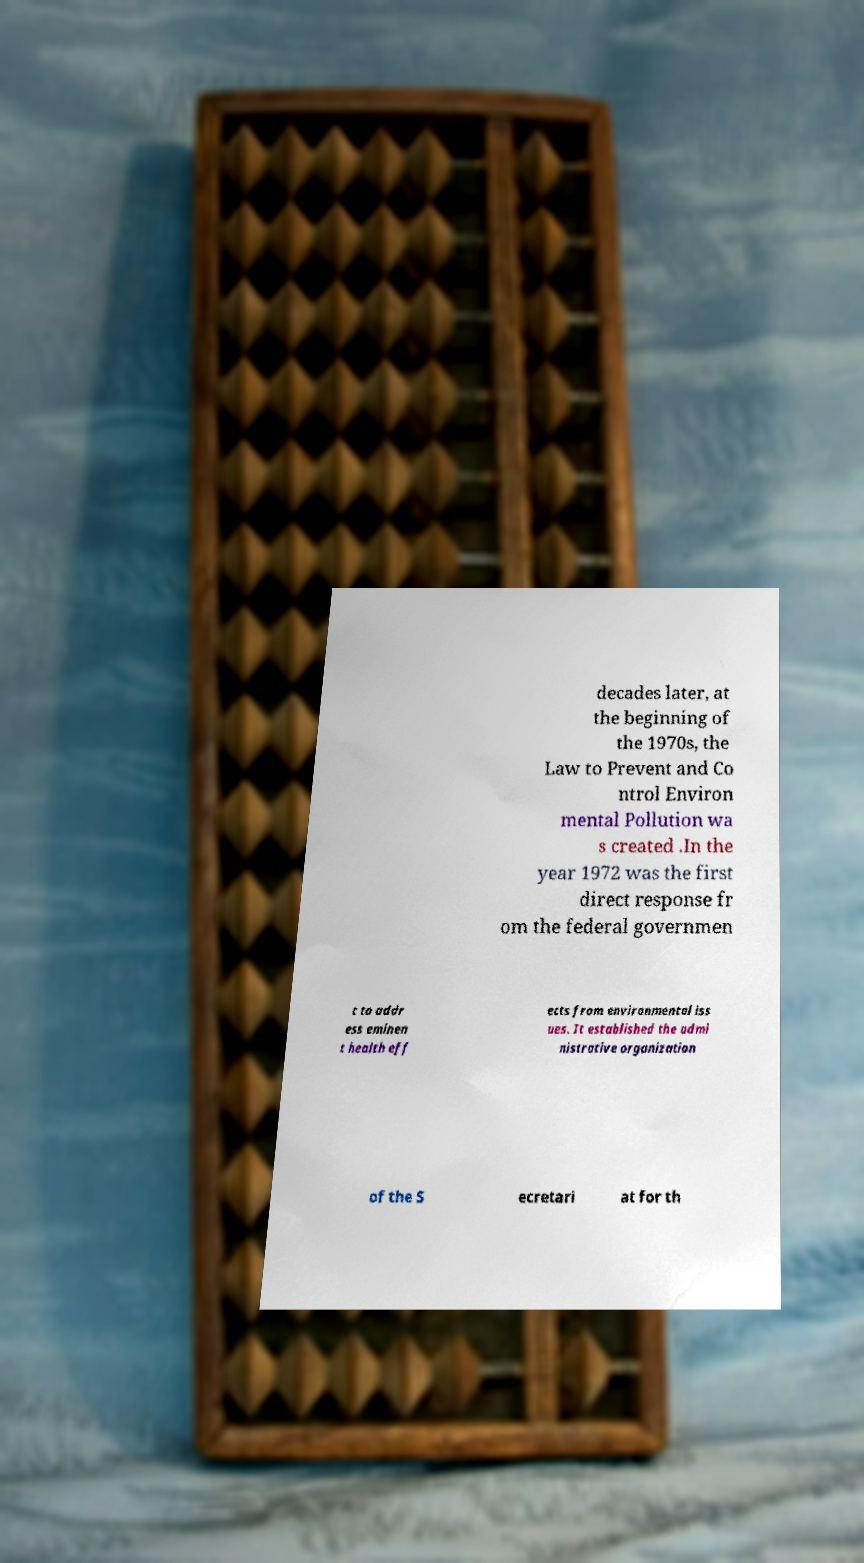There's text embedded in this image that I need extracted. Can you transcribe it verbatim? decades later, at the beginning of the 1970s, the Law to Prevent and Co ntrol Environ mental Pollution wa s created .In the year 1972 was the first direct response fr om the federal governmen t to addr ess eminen t health eff ects from environmental iss ues. It established the admi nistrative organization of the S ecretari at for th 